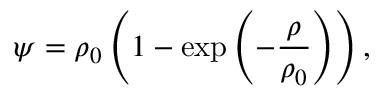<formula> <loc_0><loc_0><loc_500><loc_500>\psi = \rho _ { 0 } \left ( 1 - \exp \left ( - \frac { \rho } { \rho _ { 0 } } \right ) \right ) ,</formula> 